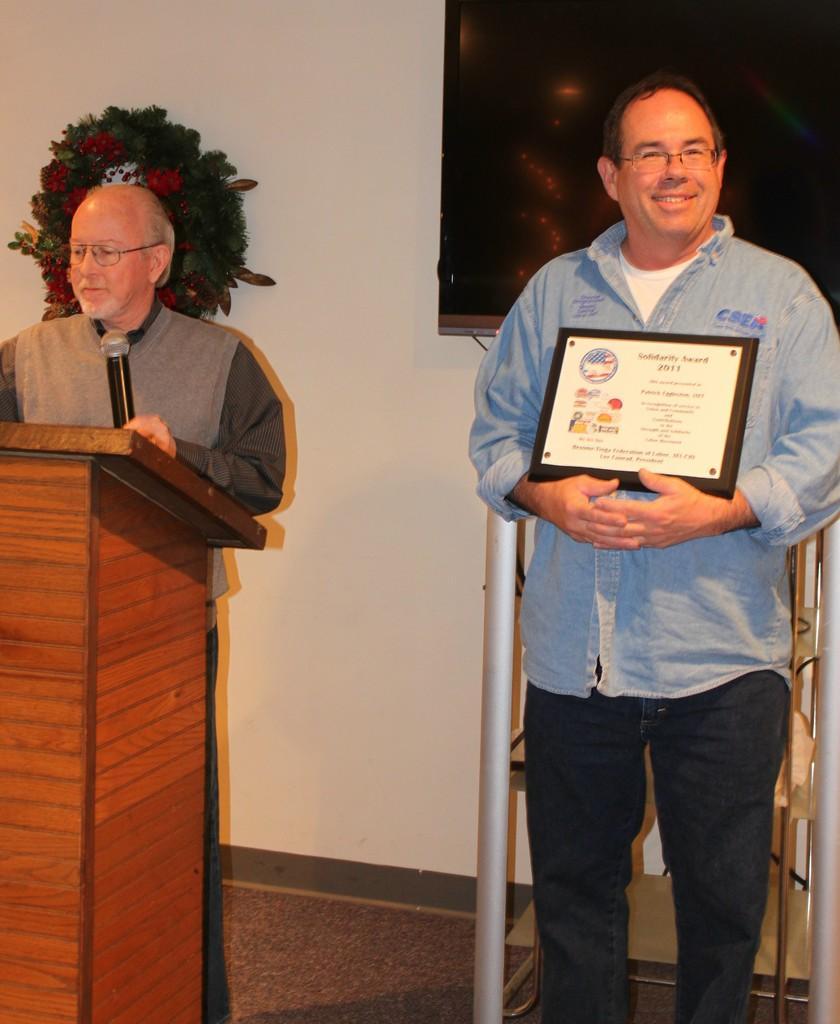Can you describe this image briefly? In this image I can see two persons standing. The person at right is wearing blue shirt, black pant and the person is holding a frame and the person at left is standing in front of the podium and holding a microphone, background I can see few flowers in red color and a frame attached to the wall and the wall is white color. 